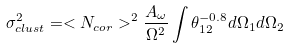Convert formula to latex. <formula><loc_0><loc_0><loc_500><loc_500>\sigma ^ { 2 } _ { c l u s t } = < N _ { c o r } > ^ { 2 } \frac { A _ { \omega } } { \Omega ^ { 2 } } \int \theta _ { 1 2 } ^ { - 0 . 8 } d \Omega _ { 1 } d \Omega _ { 2 }</formula> 